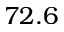Convert formula to latex. <formula><loc_0><loc_0><loc_500><loc_500>7 2 . 6</formula> 